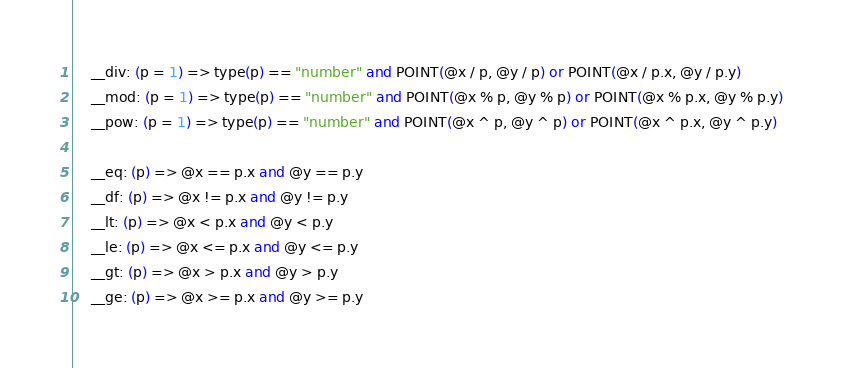Convert code to text. <code><loc_0><loc_0><loc_500><loc_500><_MoonScript_>    __div: (p = 1) => type(p) == "number" and POINT(@x / p, @y / p) or POINT(@x / p.x, @y / p.y)
    __mod: (p = 1) => type(p) == "number" and POINT(@x % p, @y % p) or POINT(@x % p.x, @y % p.y)
    __pow: (p = 1) => type(p) == "number" and POINT(@x ^ p, @y ^ p) or POINT(@x ^ p.x, @y ^ p.y)

    __eq: (p) => @x == p.x and @y == p.y
    __df: (p) => @x != p.x and @y != p.y
    __lt: (p) => @x < p.x and @y < p.y
    __le: (p) => @x <= p.x and @y <= p.y
    __gt: (p) => @x > p.x and @y > p.y
    __ge: (p) => @x >= p.x and @y >= p.y
</code> 